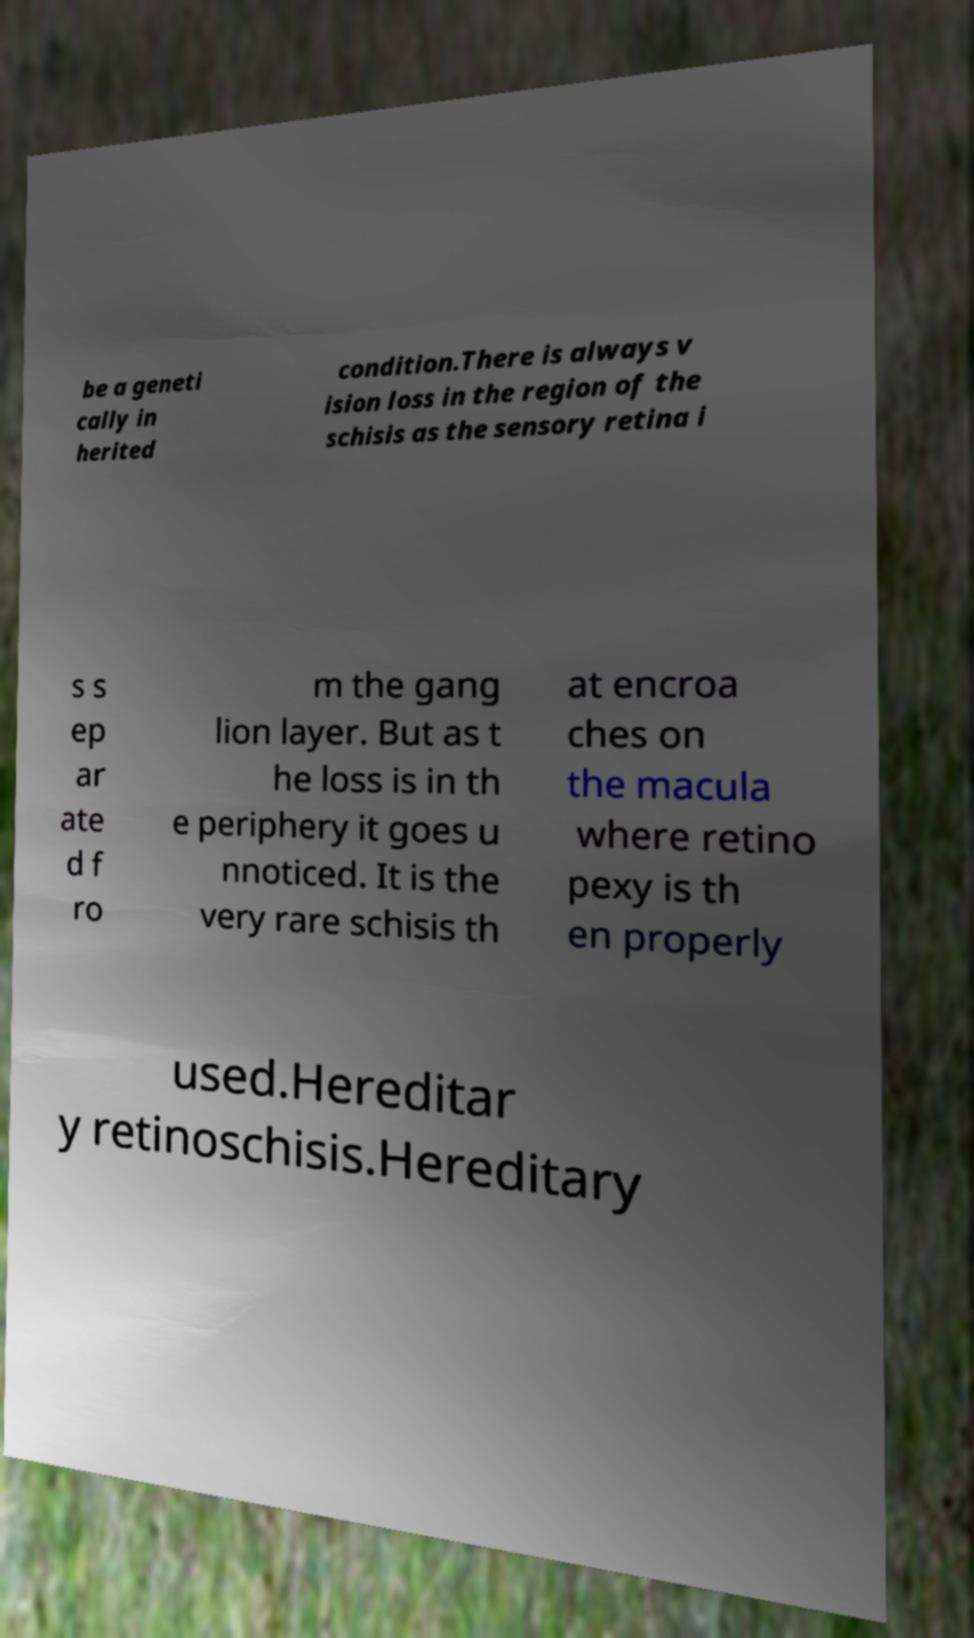I need the written content from this picture converted into text. Can you do that? be a geneti cally in herited condition.There is always v ision loss in the region of the schisis as the sensory retina i s s ep ar ate d f ro m the gang lion layer. But as t he loss is in th e periphery it goes u nnoticed. It is the very rare schisis th at encroa ches on the macula where retino pexy is th en properly used.Hereditar y retinoschisis.Hereditary 